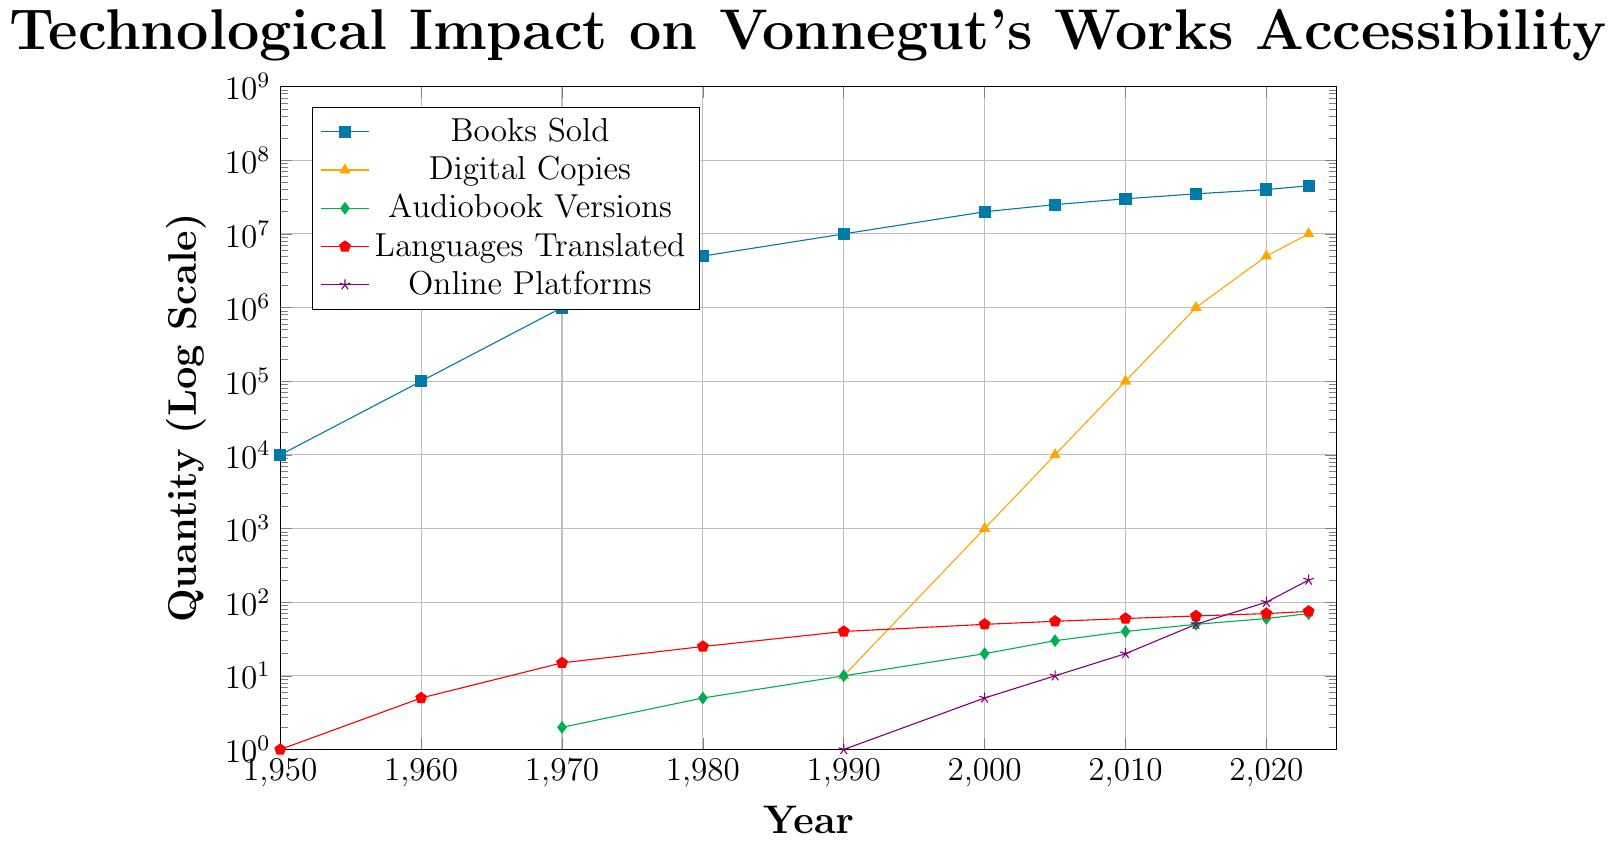What year did Vonnegut's books start having digital copies available? According to the plot, digital copies of Vonnegut's books were first available in 1990, as indicated by the introduction of non-zero values for digital copies.
Answer: 1990 In which year were there 100,000 digital copies available, and how many books were sold that year? From the plot, in 2010, there were 100,000 digital copies available, and around 30,000,000 books sold. This is indicated by the intersection of the digital copies curve at 100,000 and the books sold curve at 30,000,000.
Answer: 2010, 30,000,000 Compare the increase in the number of languages translated for the time periods 1960-1980 and 2000-2020. Which period saw a greater increase? The number of languages translated increased from 5 in 1960 to 25 in 1980 (a difference of 20). Between 2000 and 2020, the languages translated went from 50 to 70 (a difference of 20). Both periods saw an equal increase of 20 languages translated.
Answer: Both periods, equal increase What's the sum of all audiobook versions available from 1950 to 1970? According to the plot, there were 0 audiobooks in 1950 and 1960, and 2 in 1970. The sum of audiobooks for these years is 0 + 0 + 2 = 2.
Answer: 2 In which year did Vonnegut's books start to be available on online platforms, and how many platforms were there that year? The plot shows that online platforms first appear in 1990 with a value of 1. This indicates that Vonnegut's books started to be available on online platforms in 1990 with 1 platform.
Answer: 1990, 1 What is the difference in the number of books sold from 1980 to 2023? According to the plot, 5,000,000 books were sold in 1980 and 45,000,000 in 2023. The difference is 45,000,000 - 5,000,000 = 40,000,000.
Answer: 40,000,000 By how many times did the number of online platforms increase from 2000 to 2023? From the plot, there are 5 online platforms in 2000 and 200 in 2023. The number of online platforms increased by 200 / 5 = 40 times.
Answer: 40 times Estimate the average rate of increase in digital copies available between 2010 and 2020. In 2010, there are 100,000 digital copies and 5,000,000 in 2020. The increase is 5,000,000 - 100,000 = 4,900,000 over 10 years. The average rate of increase per year is 4,900,000 / 10 = 490,000.
Answer: 490,000 per year What visual characteristic might indicate the greatest technological impact on accessibility of Vonnegut’s works after the year 2000? Post-2000, the steep rise in digital copies, highlighted by a steeply upward curve, prominently indicates the technological impact. This suggests a significant increase in accessibility due to digital distribution.
Answer: Steep rise in digital copies 